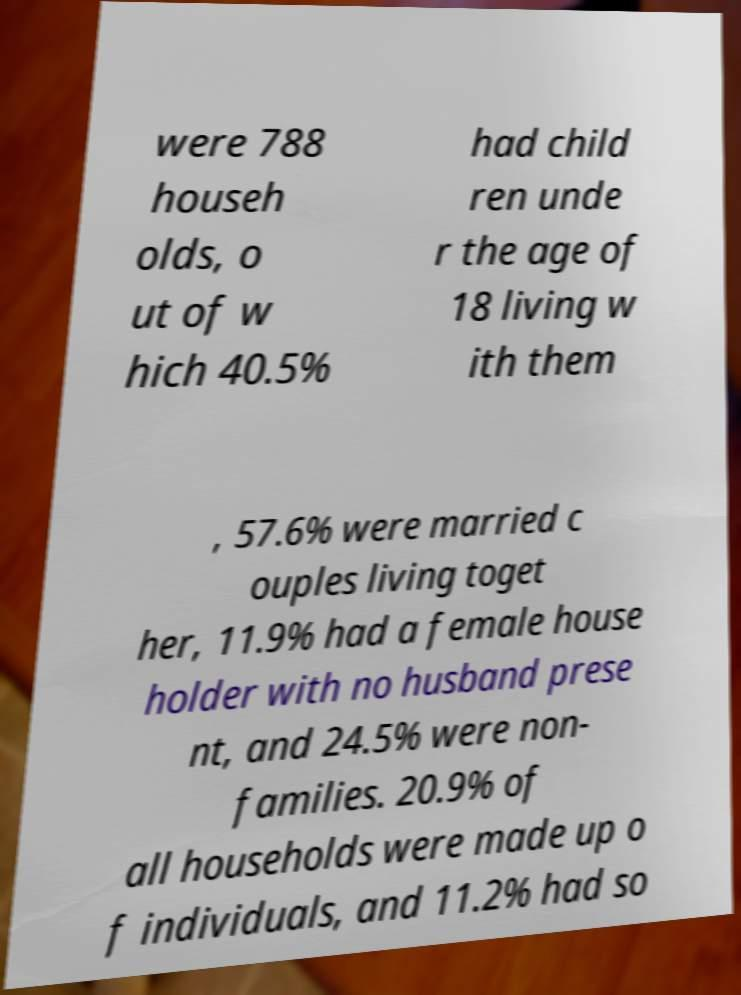Can you accurately transcribe the text from the provided image for me? were 788 househ olds, o ut of w hich 40.5% had child ren unde r the age of 18 living w ith them , 57.6% were married c ouples living toget her, 11.9% had a female house holder with no husband prese nt, and 24.5% were non- families. 20.9% of all households were made up o f individuals, and 11.2% had so 